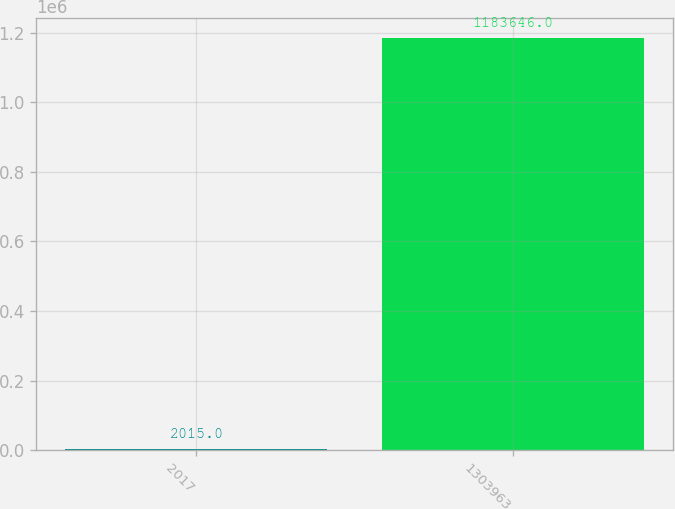Convert chart to OTSL. <chart><loc_0><loc_0><loc_500><loc_500><bar_chart><fcel>2017<fcel>1303963<nl><fcel>2015<fcel>1.18365e+06<nl></chart> 